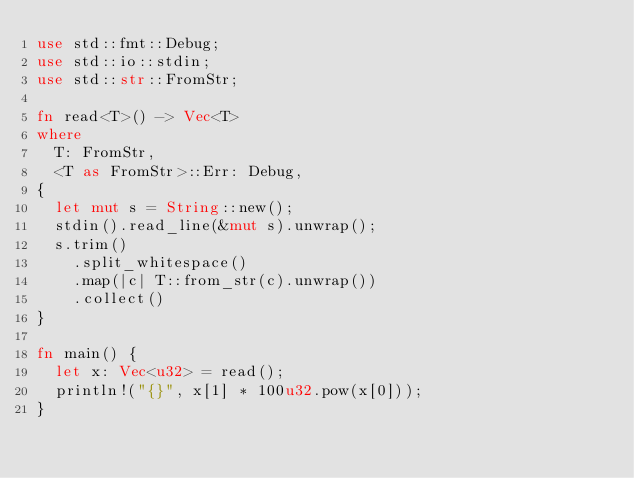<code> <loc_0><loc_0><loc_500><loc_500><_Rust_>use std::fmt::Debug;
use std::io::stdin;
use std::str::FromStr;

fn read<T>() -> Vec<T>
where
  T: FromStr,
  <T as FromStr>::Err: Debug,
{
  let mut s = String::new();
  stdin().read_line(&mut s).unwrap();
  s.trim()
    .split_whitespace()
    .map(|c| T::from_str(c).unwrap())
    .collect()
}

fn main() {
  let x: Vec<u32> = read();
  println!("{}", x[1] * 100u32.pow(x[0]));
}
</code> 